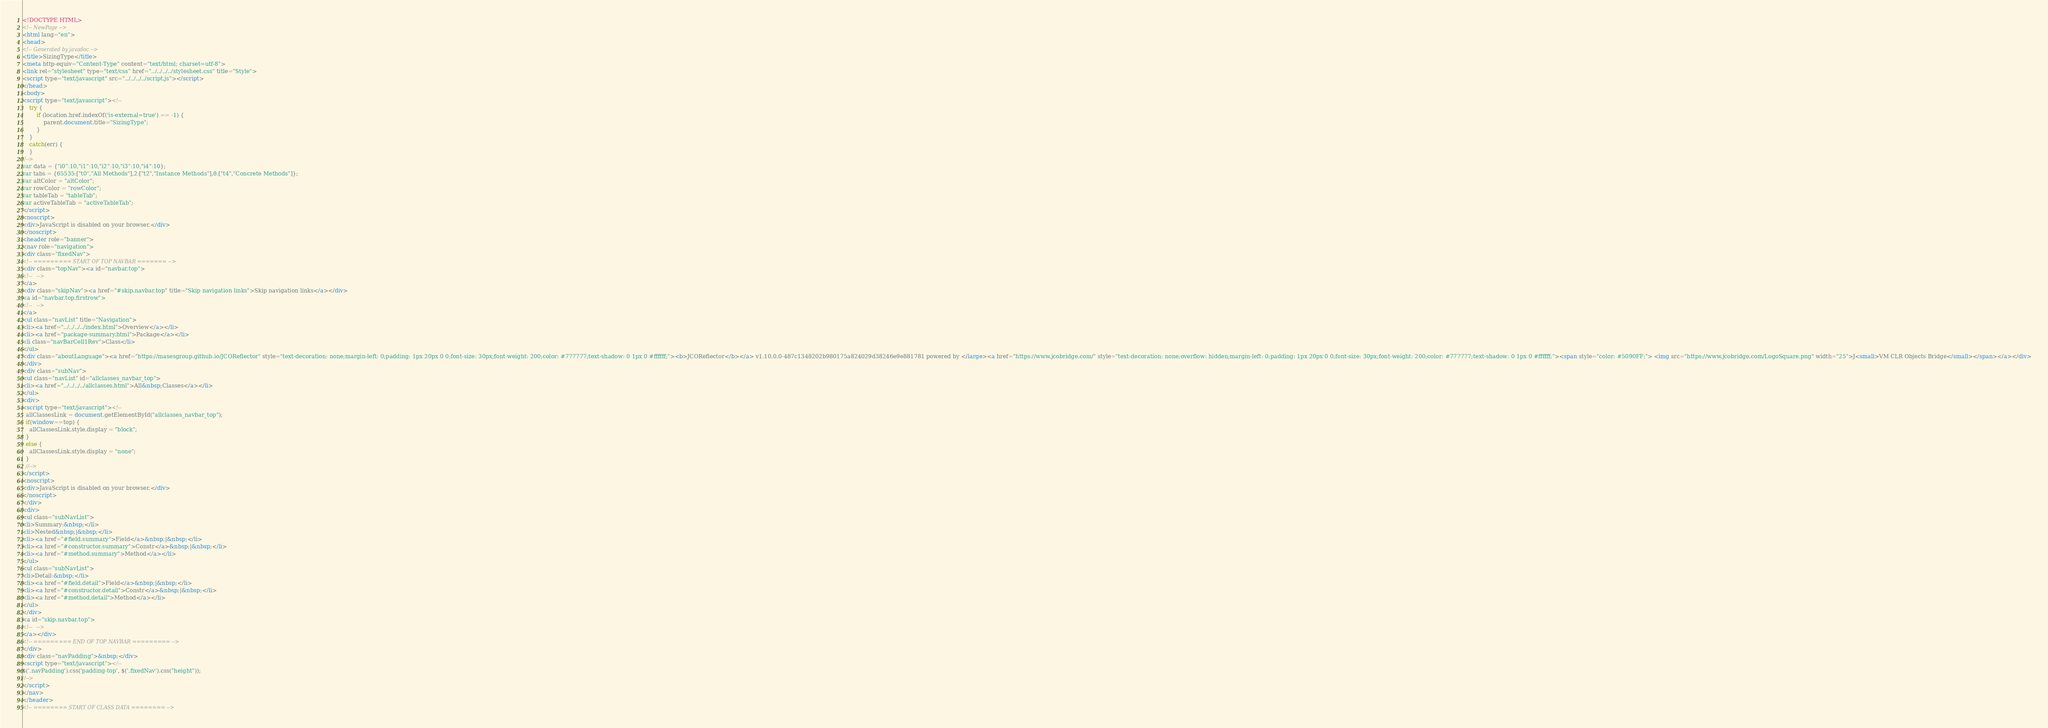<code> <loc_0><loc_0><loc_500><loc_500><_HTML_><!DOCTYPE HTML>
<!-- NewPage -->
<html lang="en">
<head>
<!-- Generated by javadoc -->
<title>SizingType</title>
<meta http-equiv="Content-Type" content="text/html; charset=utf-8">
<link rel="stylesheet" type="text/css" href="../../../../stylesheet.css" title="Style">
<script type="text/javascript" src="../../../../script.js"></script>
</head>
<body>
<script type="text/javascript"><!--
    try {
        if (location.href.indexOf('is-external=true') == -1) {
            parent.document.title="SizingType";
        }
    }
    catch(err) {
    }
//-->
var data = {"i0":10,"i1":10,"i2":10,"i3":10,"i4":10};
var tabs = {65535:["t0","All Methods"],2:["t2","Instance Methods"],8:["t4","Concrete Methods"]};
var altColor = "altColor";
var rowColor = "rowColor";
var tableTab = "tableTab";
var activeTableTab = "activeTableTab";
</script>
<noscript>
<div>JavaScript is disabled on your browser.</div>
</noscript>
<header role="banner">
<nav role="navigation">
<div class="fixedNav">
<!-- ========= START OF TOP NAVBAR ======= -->
<div class="topNav"><a id="navbar.top">
<!--   -->
</a>
<div class="skipNav"><a href="#skip.navbar.top" title="Skip navigation links">Skip navigation links</a></div>
<a id="navbar.top.firstrow">
<!--   -->
</a>
<ul class="navList" title="Navigation">
<li><a href="../../../../index.html">Overview</a></li>
<li><a href="package-summary.html">Package</a></li>
<li class="navBarCell1Rev">Class</li>
</ul>
<div class="aboutLanguage"><a href="https://masesgroup.github.io/JCOReflector" style="text-decoration: none;margin-left: 0;padding: 1px 20px 0 0;font-size: 30px;font-weight: 200;color: #777777;text-shadow: 0 1px 0 #ffffff;"><b>JCOReflector</b></a> v1.10.0.0-487c1348202b980175a824029d38246e9e881781 powered by </large><a href="https://www.jcobridge.com/" style="text-decoration: none;overflow: hidden;margin-left: 0;padding: 1px 20px 0 0;font-size: 30px;font-weight: 200;color: #777777;text-shadow: 0 1px 0 #ffffff;"><span style="color: #5090FF;"> <img src="https://www.jcobridge.com/LogoSquare.png" width="25">J<small>VM CLR Objects Bridge</small></span></a></div>
</div>
<div class="subNav">
<ul class="navList" id="allclasses_navbar_top">
<li><a href="../../../../allclasses.html">All&nbsp;Classes</a></li>
</ul>
<div>
<script type="text/javascript"><!--
  allClassesLink = document.getElementById("allclasses_navbar_top");
  if(window==top) {
    allClassesLink.style.display = "block";
  }
  else {
    allClassesLink.style.display = "none";
  }
  //-->
</script>
<noscript>
<div>JavaScript is disabled on your browser.</div>
</noscript>
</div>
<div>
<ul class="subNavList">
<li>Summary:&nbsp;</li>
<li>Nested&nbsp;|&nbsp;</li>
<li><a href="#field.summary">Field</a>&nbsp;|&nbsp;</li>
<li><a href="#constructor.summary">Constr</a>&nbsp;|&nbsp;</li>
<li><a href="#method.summary">Method</a></li>
</ul>
<ul class="subNavList">
<li>Detail:&nbsp;</li>
<li><a href="#field.detail">Field</a>&nbsp;|&nbsp;</li>
<li><a href="#constructor.detail">Constr</a>&nbsp;|&nbsp;</li>
<li><a href="#method.detail">Method</a></li>
</ul>
</div>
<a id="skip.navbar.top">
<!--   -->
</a></div>
<!-- ========= END OF TOP NAVBAR ========= -->
</div>
<div class="navPadding">&nbsp;</div>
<script type="text/javascript"><!--
$('.navPadding').css('padding-top', $('.fixedNav').css("height"));
//-->
</script>
</nav>
</header>
<!-- ======== START OF CLASS DATA ======== --></code> 